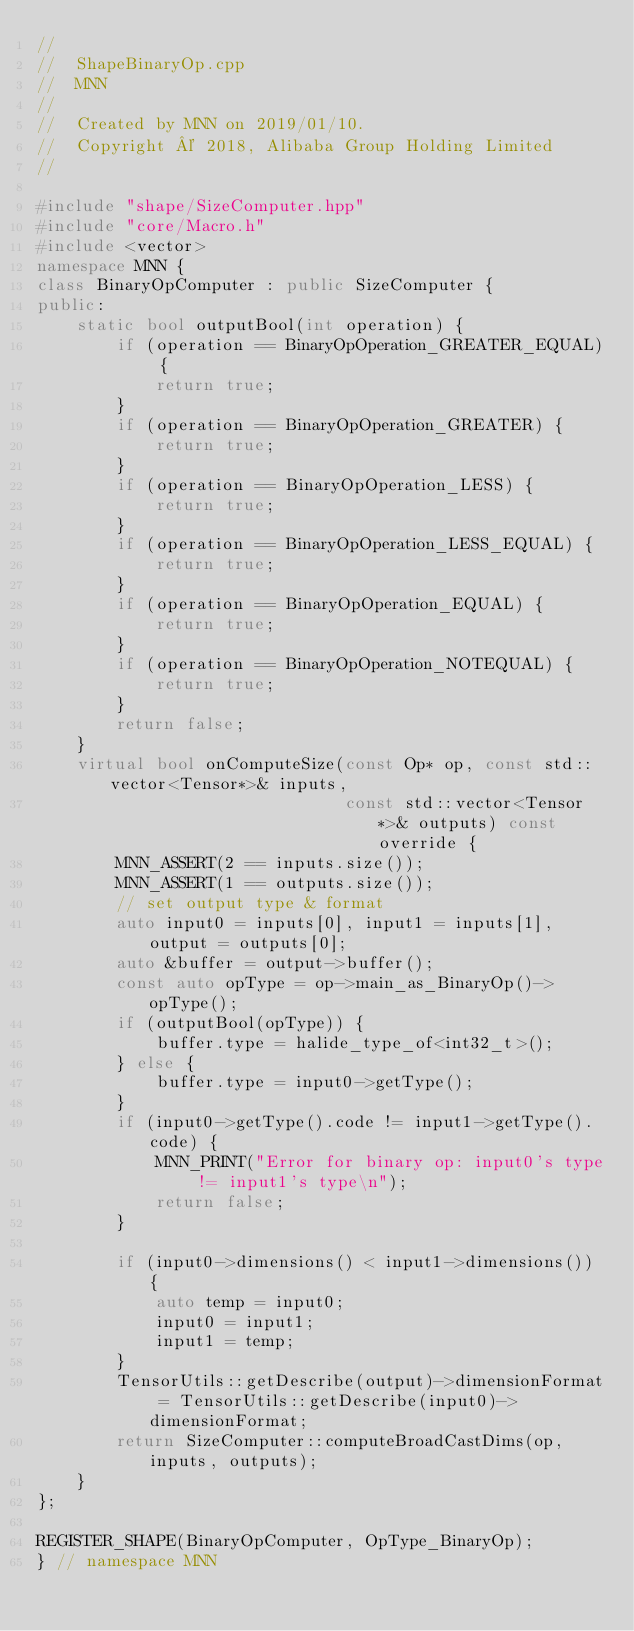Convert code to text. <code><loc_0><loc_0><loc_500><loc_500><_C++_>//
//  ShapeBinaryOp.cpp
//  MNN
//
//  Created by MNN on 2019/01/10.
//  Copyright © 2018, Alibaba Group Holding Limited
//

#include "shape/SizeComputer.hpp"
#include "core/Macro.h"
#include <vector>
namespace MNN {
class BinaryOpComputer : public SizeComputer {
public:
    static bool outputBool(int operation) {
        if (operation == BinaryOpOperation_GREATER_EQUAL) {
            return true;
        }
        if (operation == BinaryOpOperation_GREATER) {
            return true;
        }
        if (operation == BinaryOpOperation_LESS) {
            return true;
        }
        if (operation == BinaryOpOperation_LESS_EQUAL) {
            return true;
        }
        if (operation == BinaryOpOperation_EQUAL) {
            return true;
        }
        if (operation == BinaryOpOperation_NOTEQUAL) {
            return true;
        }
        return false;
    }
    virtual bool onComputeSize(const Op* op, const std::vector<Tensor*>& inputs,
                               const std::vector<Tensor*>& outputs) const override {
        MNN_ASSERT(2 == inputs.size());
        MNN_ASSERT(1 == outputs.size());
        // set output type & format
        auto input0 = inputs[0], input1 = inputs[1], output = outputs[0];
        auto &buffer = output->buffer();
        const auto opType = op->main_as_BinaryOp()->opType();
        if (outputBool(opType)) {
            buffer.type = halide_type_of<int32_t>();
        } else {
            buffer.type = input0->getType();
        }
        if (input0->getType().code != input1->getType().code) {
            MNN_PRINT("Error for binary op: input0's type != input1's type\n");
            return false;
        }

        if (input0->dimensions() < input1->dimensions()) {
            auto temp = input0;
            input0 = input1;
            input1 = temp;
        }
        TensorUtils::getDescribe(output)->dimensionFormat = TensorUtils::getDescribe(input0)->dimensionFormat;
        return SizeComputer::computeBroadCastDims(op, inputs, outputs);
    }
};

REGISTER_SHAPE(BinaryOpComputer, OpType_BinaryOp);
} // namespace MNN
</code> 